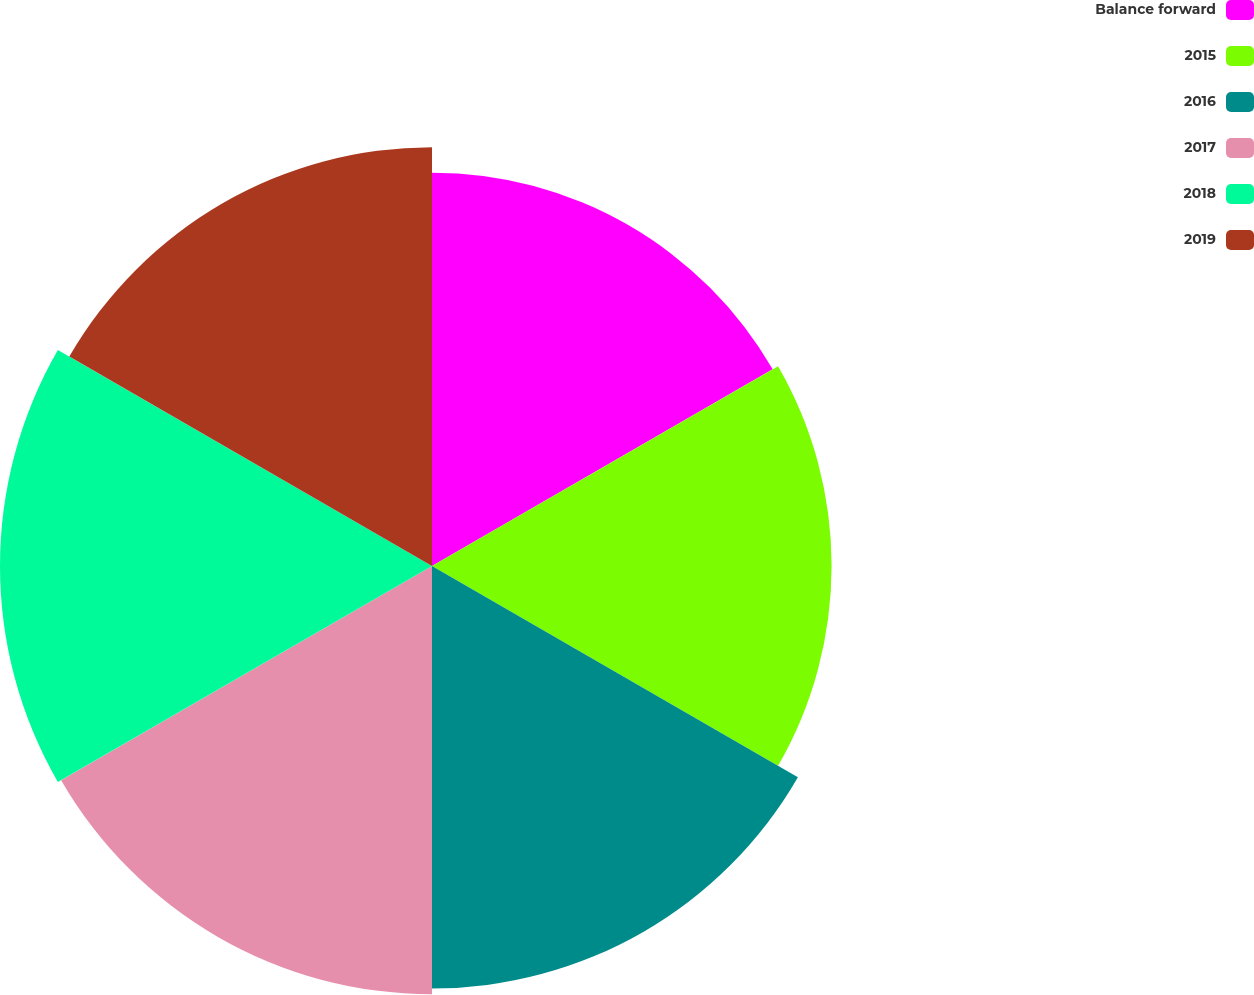Convert chart. <chart><loc_0><loc_0><loc_500><loc_500><pie_chart><fcel>Balance forward<fcel>2015<fcel>2016<fcel>2017<fcel>2018<fcel>2019<nl><fcel>15.77%<fcel>16.02%<fcel>16.94%<fcel>17.17%<fcel>17.32%<fcel>16.79%<nl></chart> 